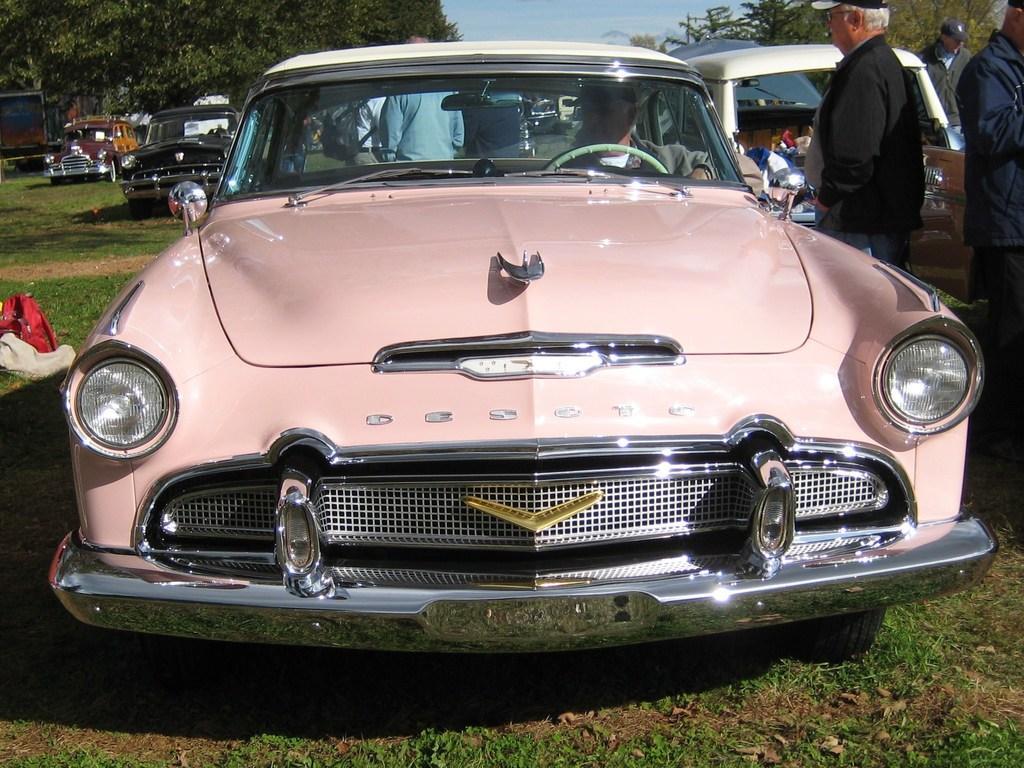Could you give a brief overview of what you see in this image? Here in the front we can see a car and there is a man sitting inside the car and beside it there are couple of people Standing and behind the car there are also several cars, there are trees everywhere 